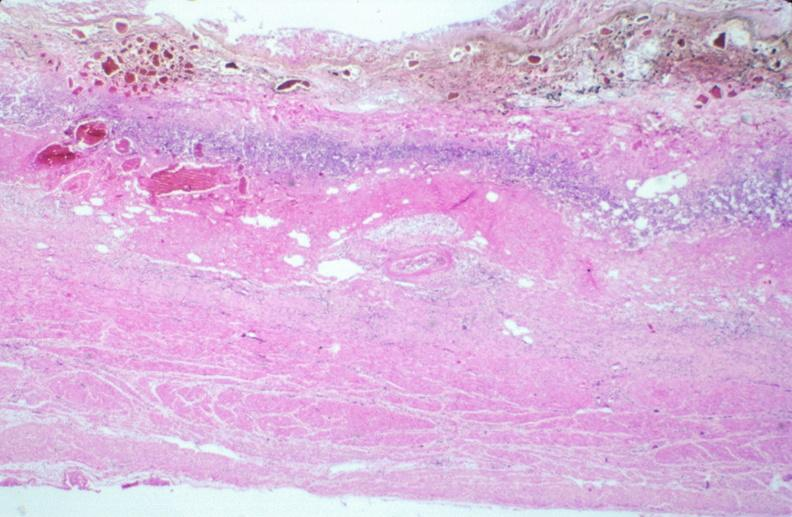where is this from?
Answer the question using a single word or phrase. Gastrointestinal system 